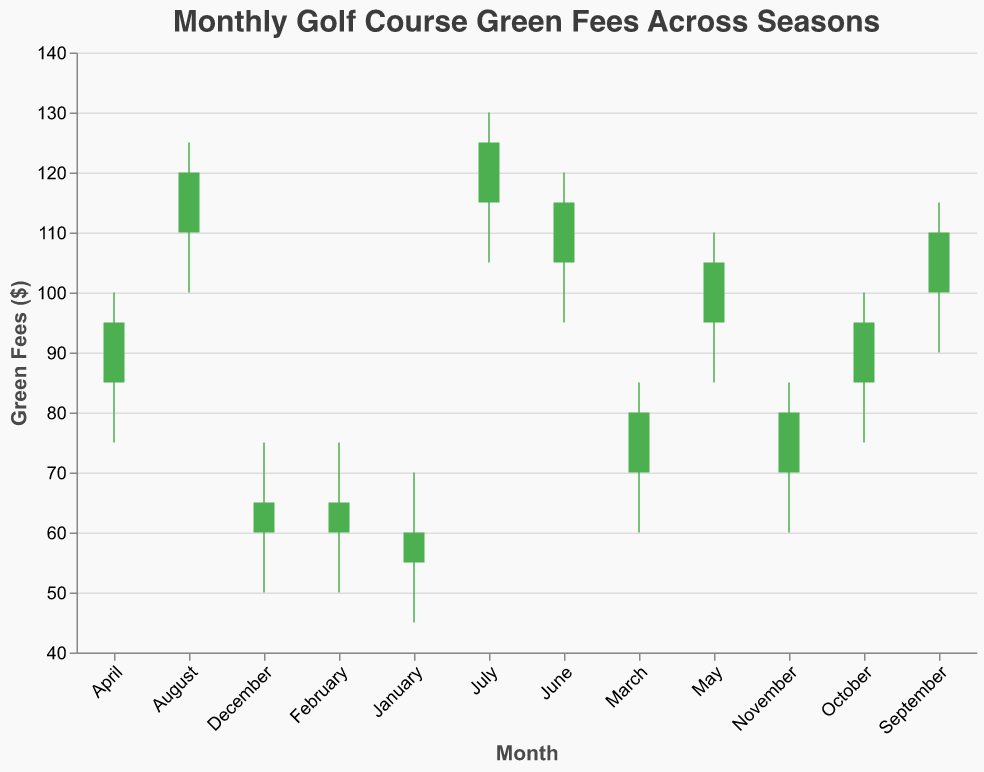What is the title of the figure? The title of the figure is displayed at the top and it reads "Monthly Golf Course Green Fees Across Seasons".
Answer: Monthly Golf Course Green Fees Across Seasons Which month shows the highest green fee? The highest green fee is shown as a vertical bar reaching up to the 'High' value for each month. July has the highest 'High' value at 130.
Answer: July In which month did the green fees increase the most from the open to the close? The increase in green fees from open to close can be seen where the vertical bar is green (Open < Close). April shows the highest increase with Open at 85 and Close at 95, a difference of 10.
Answer: April Which months have green fees that closed lower than they opened? Red bars indicate that the green fees closed lower than they opened (Open > Close). January, August, and September have red bars.
Answer: January, August, September What are the green fees for November? The values can be observed directly for November: Open is 70, High is 85, Low is 60, and Close is 80.
Answer: Open: 70, High: 85, Low: 60, Close: 80 Which month had the smallest range between the high and low green fees? The range between high and low green fees for each month can be calculated. December has the smallest range of 25 (75 - 50).
Answer: December How do green fees trend across the months from January to July? Observing the green fee values from January to July, the general trend is an increase in both the Open and Close values.
Answer: Increasing What is the average closing green fee across all months? Sum of all Close values (60+65+80+95+105+115+125+120+110+95+80+65) is 1115. There are 12 months, so 1115/12 = 92.9
Answer: 92.9 Compare the range within months of peak (July) and lowest (January) green fees. For July, the range is 130 - 105 = 25. For January, the range is 70 - 45 = 25. Both months have the same range.
Answer: 25 (both months) Which month had the highest difference between the opening and closing green fee? The difference can be calculated for each month; July has the highest difference, with an Open at 115 and Close at 125, giving a difference of 10.
Answer: July 